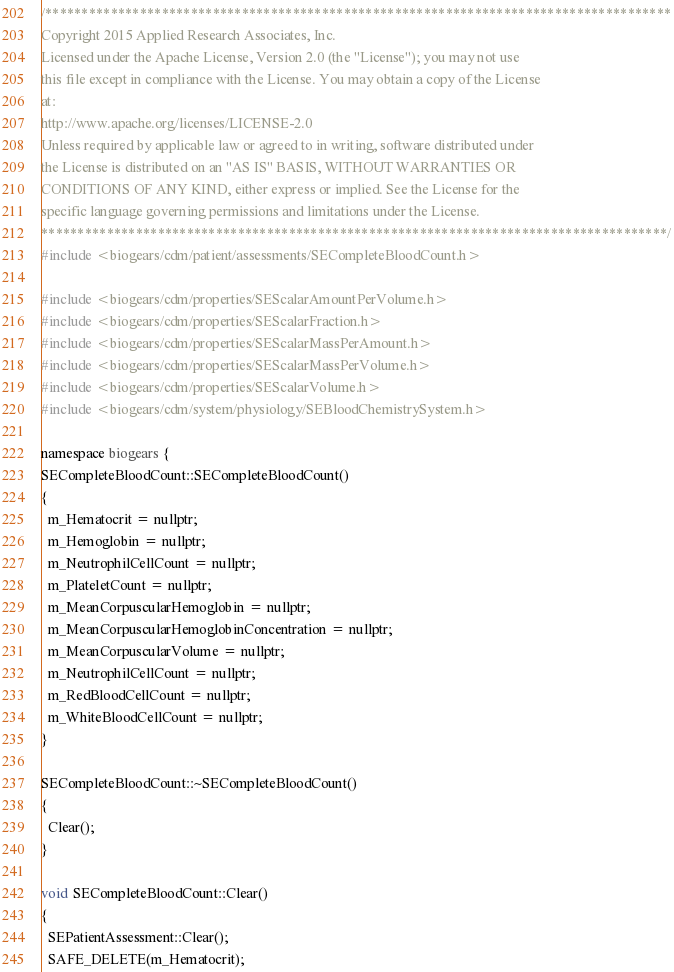<code> <loc_0><loc_0><loc_500><loc_500><_C++_>/**************************************************************************************
Copyright 2015 Applied Research Associates, Inc.
Licensed under the Apache License, Version 2.0 (the "License"); you may not use
this file except in compliance with the License. You may obtain a copy of the License
at:
http://www.apache.org/licenses/LICENSE-2.0
Unless required by applicable law or agreed to in writing, software distributed under
the License is distributed on an "AS IS" BASIS, WITHOUT WARRANTIES OR
CONDITIONS OF ANY KIND, either express or implied. See the License for the
specific language governing permissions and limitations under the License.
**************************************************************************************/
#include <biogears/cdm/patient/assessments/SECompleteBloodCount.h>

#include <biogears/cdm/properties/SEScalarAmountPerVolume.h>
#include <biogears/cdm/properties/SEScalarFraction.h>
#include <biogears/cdm/properties/SEScalarMassPerAmount.h>
#include <biogears/cdm/properties/SEScalarMassPerVolume.h>
#include <biogears/cdm/properties/SEScalarVolume.h>
#include <biogears/cdm/system/physiology/SEBloodChemistrySystem.h>

namespace biogears {
SECompleteBloodCount::SECompleteBloodCount()
{
  m_Hematocrit = nullptr;
  m_Hemoglobin = nullptr;
  m_NeutrophilCellCount = nullptr;
  m_PlateletCount = nullptr;
  m_MeanCorpuscularHemoglobin = nullptr;
  m_MeanCorpuscularHemoglobinConcentration = nullptr;
  m_MeanCorpuscularVolume = nullptr;
  m_NeutrophilCellCount = nullptr;
  m_RedBloodCellCount = nullptr;
  m_WhiteBloodCellCount = nullptr;
}

SECompleteBloodCount::~SECompleteBloodCount()
{
  Clear();
}

void SECompleteBloodCount::Clear()
{
  SEPatientAssessment::Clear();
  SAFE_DELETE(m_Hematocrit);</code> 